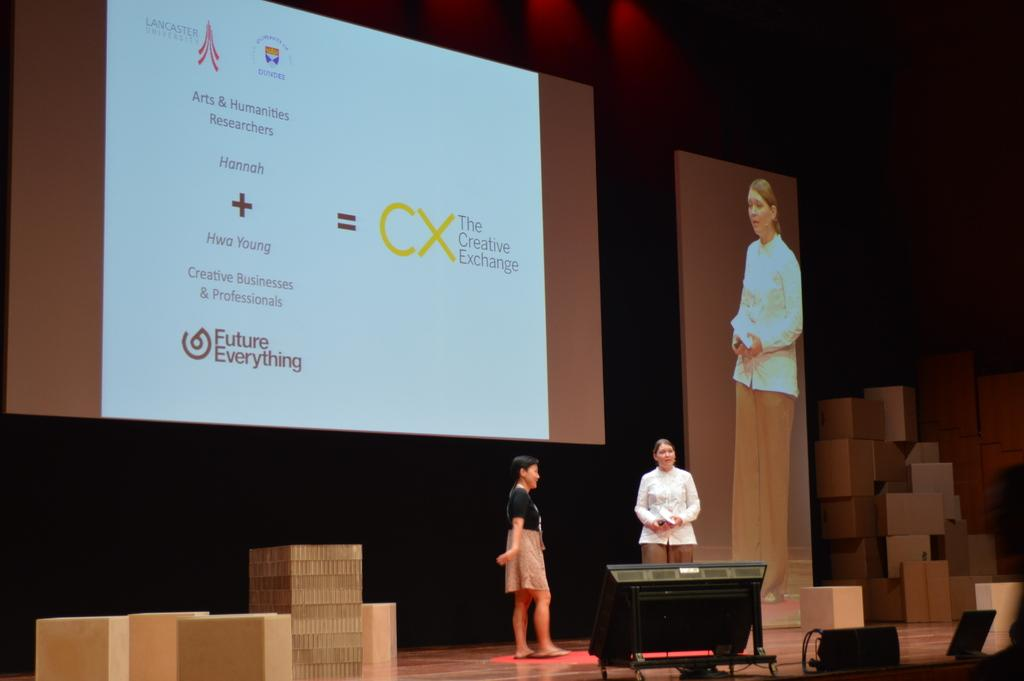How many people are in the image? There are two persons in the image. What can be seen on the screens in the image? There are two screens with text, symbols, and a picture of a person on them. What else is present in the image besides the screens and people? There are boxes and electronic objects on the stage. Can you tell me how many worms are crawling on the stage in the image? There are no worms present in the image; the focus is on the people, screens, boxes, and electronic objects. 